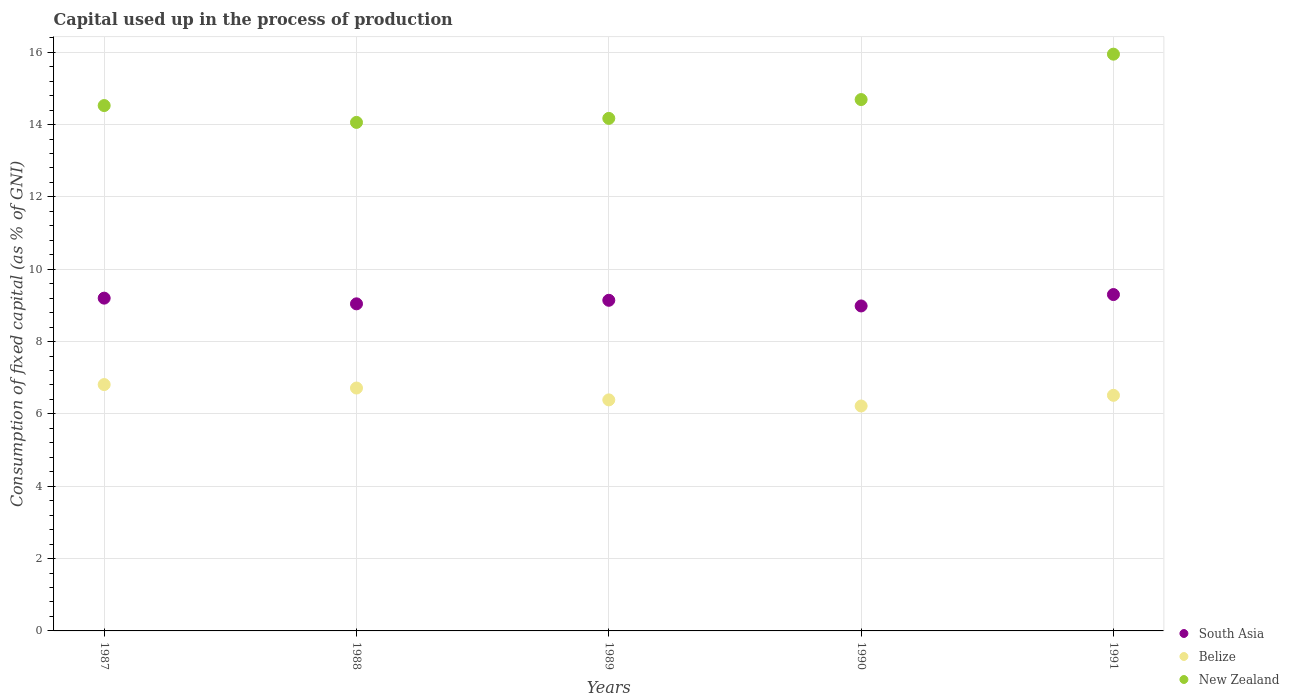What is the capital used up in the process of production in New Zealand in 1987?
Provide a succinct answer. 14.53. Across all years, what is the maximum capital used up in the process of production in South Asia?
Keep it short and to the point. 9.3. Across all years, what is the minimum capital used up in the process of production in Belize?
Provide a succinct answer. 6.22. What is the total capital used up in the process of production in South Asia in the graph?
Give a very brief answer. 45.67. What is the difference between the capital used up in the process of production in South Asia in 1989 and that in 1991?
Give a very brief answer. -0.16. What is the difference between the capital used up in the process of production in New Zealand in 1991 and the capital used up in the process of production in Belize in 1990?
Give a very brief answer. 9.73. What is the average capital used up in the process of production in New Zealand per year?
Make the answer very short. 14.68. In the year 1990, what is the difference between the capital used up in the process of production in New Zealand and capital used up in the process of production in Belize?
Provide a short and direct response. 8.47. What is the ratio of the capital used up in the process of production in South Asia in 1990 to that in 1991?
Your response must be concise. 0.97. Is the capital used up in the process of production in Belize in 1987 less than that in 1990?
Provide a short and direct response. No. Is the difference between the capital used up in the process of production in New Zealand in 1990 and 1991 greater than the difference between the capital used up in the process of production in Belize in 1990 and 1991?
Provide a succinct answer. No. What is the difference between the highest and the second highest capital used up in the process of production in South Asia?
Offer a terse response. 0.1. What is the difference between the highest and the lowest capital used up in the process of production in New Zealand?
Make the answer very short. 1.89. In how many years, is the capital used up in the process of production in South Asia greater than the average capital used up in the process of production in South Asia taken over all years?
Make the answer very short. 3. Is it the case that in every year, the sum of the capital used up in the process of production in Belize and capital used up in the process of production in South Asia  is greater than the capital used up in the process of production in New Zealand?
Give a very brief answer. No. Does the capital used up in the process of production in South Asia monotonically increase over the years?
Keep it short and to the point. No. Is the capital used up in the process of production in Belize strictly greater than the capital used up in the process of production in South Asia over the years?
Your answer should be very brief. No. Is the capital used up in the process of production in South Asia strictly less than the capital used up in the process of production in Belize over the years?
Make the answer very short. No. How many years are there in the graph?
Your answer should be very brief. 5. What is the difference between two consecutive major ticks on the Y-axis?
Offer a very short reply. 2. Does the graph contain any zero values?
Make the answer very short. No. Does the graph contain grids?
Provide a succinct answer. Yes. Where does the legend appear in the graph?
Offer a very short reply. Bottom right. How are the legend labels stacked?
Make the answer very short. Vertical. What is the title of the graph?
Ensure brevity in your answer.  Capital used up in the process of production. What is the label or title of the Y-axis?
Offer a terse response. Consumption of fixed capital (as % of GNI). What is the Consumption of fixed capital (as % of GNI) in South Asia in 1987?
Provide a succinct answer. 9.2. What is the Consumption of fixed capital (as % of GNI) of Belize in 1987?
Offer a very short reply. 6.81. What is the Consumption of fixed capital (as % of GNI) of New Zealand in 1987?
Provide a succinct answer. 14.53. What is the Consumption of fixed capital (as % of GNI) in South Asia in 1988?
Your answer should be compact. 9.04. What is the Consumption of fixed capital (as % of GNI) of Belize in 1988?
Your answer should be very brief. 6.72. What is the Consumption of fixed capital (as % of GNI) of New Zealand in 1988?
Provide a succinct answer. 14.06. What is the Consumption of fixed capital (as % of GNI) in South Asia in 1989?
Your answer should be compact. 9.14. What is the Consumption of fixed capital (as % of GNI) in Belize in 1989?
Make the answer very short. 6.39. What is the Consumption of fixed capital (as % of GNI) of New Zealand in 1989?
Provide a succinct answer. 14.17. What is the Consumption of fixed capital (as % of GNI) of South Asia in 1990?
Make the answer very short. 8.99. What is the Consumption of fixed capital (as % of GNI) in Belize in 1990?
Make the answer very short. 6.22. What is the Consumption of fixed capital (as % of GNI) of New Zealand in 1990?
Provide a succinct answer. 14.69. What is the Consumption of fixed capital (as % of GNI) of South Asia in 1991?
Keep it short and to the point. 9.3. What is the Consumption of fixed capital (as % of GNI) of Belize in 1991?
Offer a very short reply. 6.51. What is the Consumption of fixed capital (as % of GNI) in New Zealand in 1991?
Keep it short and to the point. 15.95. Across all years, what is the maximum Consumption of fixed capital (as % of GNI) of South Asia?
Keep it short and to the point. 9.3. Across all years, what is the maximum Consumption of fixed capital (as % of GNI) of Belize?
Ensure brevity in your answer.  6.81. Across all years, what is the maximum Consumption of fixed capital (as % of GNI) of New Zealand?
Your answer should be compact. 15.95. Across all years, what is the minimum Consumption of fixed capital (as % of GNI) in South Asia?
Offer a very short reply. 8.99. Across all years, what is the minimum Consumption of fixed capital (as % of GNI) in Belize?
Make the answer very short. 6.22. Across all years, what is the minimum Consumption of fixed capital (as % of GNI) in New Zealand?
Your answer should be very brief. 14.06. What is the total Consumption of fixed capital (as % of GNI) of South Asia in the graph?
Keep it short and to the point. 45.67. What is the total Consumption of fixed capital (as % of GNI) of Belize in the graph?
Ensure brevity in your answer.  32.65. What is the total Consumption of fixed capital (as % of GNI) in New Zealand in the graph?
Your answer should be compact. 73.4. What is the difference between the Consumption of fixed capital (as % of GNI) in South Asia in 1987 and that in 1988?
Provide a short and direct response. 0.16. What is the difference between the Consumption of fixed capital (as % of GNI) of Belize in 1987 and that in 1988?
Ensure brevity in your answer.  0.1. What is the difference between the Consumption of fixed capital (as % of GNI) of New Zealand in 1987 and that in 1988?
Your answer should be compact. 0.47. What is the difference between the Consumption of fixed capital (as % of GNI) of South Asia in 1987 and that in 1989?
Make the answer very short. 0.06. What is the difference between the Consumption of fixed capital (as % of GNI) of Belize in 1987 and that in 1989?
Keep it short and to the point. 0.42. What is the difference between the Consumption of fixed capital (as % of GNI) of New Zealand in 1987 and that in 1989?
Give a very brief answer. 0.35. What is the difference between the Consumption of fixed capital (as % of GNI) in South Asia in 1987 and that in 1990?
Your answer should be compact. 0.22. What is the difference between the Consumption of fixed capital (as % of GNI) of Belize in 1987 and that in 1990?
Make the answer very short. 0.59. What is the difference between the Consumption of fixed capital (as % of GNI) of New Zealand in 1987 and that in 1990?
Provide a succinct answer. -0.17. What is the difference between the Consumption of fixed capital (as % of GNI) in South Asia in 1987 and that in 1991?
Keep it short and to the point. -0.1. What is the difference between the Consumption of fixed capital (as % of GNI) of Belize in 1987 and that in 1991?
Your answer should be very brief. 0.3. What is the difference between the Consumption of fixed capital (as % of GNI) of New Zealand in 1987 and that in 1991?
Offer a terse response. -1.42. What is the difference between the Consumption of fixed capital (as % of GNI) in South Asia in 1988 and that in 1989?
Your answer should be compact. -0.1. What is the difference between the Consumption of fixed capital (as % of GNI) in Belize in 1988 and that in 1989?
Keep it short and to the point. 0.33. What is the difference between the Consumption of fixed capital (as % of GNI) of New Zealand in 1988 and that in 1989?
Ensure brevity in your answer.  -0.11. What is the difference between the Consumption of fixed capital (as % of GNI) of South Asia in 1988 and that in 1990?
Offer a terse response. 0.06. What is the difference between the Consumption of fixed capital (as % of GNI) in Belize in 1988 and that in 1990?
Provide a short and direct response. 0.5. What is the difference between the Consumption of fixed capital (as % of GNI) of New Zealand in 1988 and that in 1990?
Your response must be concise. -0.63. What is the difference between the Consumption of fixed capital (as % of GNI) of South Asia in 1988 and that in 1991?
Keep it short and to the point. -0.26. What is the difference between the Consumption of fixed capital (as % of GNI) in Belize in 1988 and that in 1991?
Ensure brevity in your answer.  0.2. What is the difference between the Consumption of fixed capital (as % of GNI) of New Zealand in 1988 and that in 1991?
Make the answer very short. -1.89. What is the difference between the Consumption of fixed capital (as % of GNI) of South Asia in 1989 and that in 1990?
Your answer should be very brief. 0.16. What is the difference between the Consumption of fixed capital (as % of GNI) of Belize in 1989 and that in 1990?
Provide a short and direct response. 0.17. What is the difference between the Consumption of fixed capital (as % of GNI) in New Zealand in 1989 and that in 1990?
Make the answer very short. -0.52. What is the difference between the Consumption of fixed capital (as % of GNI) of South Asia in 1989 and that in 1991?
Ensure brevity in your answer.  -0.16. What is the difference between the Consumption of fixed capital (as % of GNI) of Belize in 1989 and that in 1991?
Give a very brief answer. -0.13. What is the difference between the Consumption of fixed capital (as % of GNI) in New Zealand in 1989 and that in 1991?
Offer a terse response. -1.78. What is the difference between the Consumption of fixed capital (as % of GNI) in South Asia in 1990 and that in 1991?
Provide a succinct answer. -0.32. What is the difference between the Consumption of fixed capital (as % of GNI) in Belize in 1990 and that in 1991?
Offer a very short reply. -0.3. What is the difference between the Consumption of fixed capital (as % of GNI) in New Zealand in 1990 and that in 1991?
Your answer should be very brief. -1.26. What is the difference between the Consumption of fixed capital (as % of GNI) in South Asia in 1987 and the Consumption of fixed capital (as % of GNI) in Belize in 1988?
Provide a succinct answer. 2.49. What is the difference between the Consumption of fixed capital (as % of GNI) in South Asia in 1987 and the Consumption of fixed capital (as % of GNI) in New Zealand in 1988?
Offer a terse response. -4.86. What is the difference between the Consumption of fixed capital (as % of GNI) of Belize in 1987 and the Consumption of fixed capital (as % of GNI) of New Zealand in 1988?
Give a very brief answer. -7.25. What is the difference between the Consumption of fixed capital (as % of GNI) in South Asia in 1987 and the Consumption of fixed capital (as % of GNI) in Belize in 1989?
Give a very brief answer. 2.81. What is the difference between the Consumption of fixed capital (as % of GNI) in South Asia in 1987 and the Consumption of fixed capital (as % of GNI) in New Zealand in 1989?
Ensure brevity in your answer.  -4.97. What is the difference between the Consumption of fixed capital (as % of GNI) in Belize in 1987 and the Consumption of fixed capital (as % of GNI) in New Zealand in 1989?
Your answer should be very brief. -7.36. What is the difference between the Consumption of fixed capital (as % of GNI) of South Asia in 1987 and the Consumption of fixed capital (as % of GNI) of Belize in 1990?
Ensure brevity in your answer.  2.98. What is the difference between the Consumption of fixed capital (as % of GNI) in South Asia in 1987 and the Consumption of fixed capital (as % of GNI) in New Zealand in 1990?
Provide a succinct answer. -5.49. What is the difference between the Consumption of fixed capital (as % of GNI) of Belize in 1987 and the Consumption of fixed capital (as % of GNI) of New Zealand in 1990?
Make the answer very short. -7.88. What is the difference between the Consumption of fixed capital (as % of GNI) of South Asia in 1987 and the Consumption of fixed capital (as % of GNI) of Belize in 1991?
Offer a very short reply. 2.69. What is the difference between the Consumption of fixed capital (as % of GNI) of South Asia in 1987 and the Consumption of fixed capital (as % of GNI) of New Zealand in 1991?
Make the answer very short. -6.75. What is the difference between the Consumption of fixed capital (as % of GNI) in Belize in 1987 and the Consumption of fixed capital (as % of GNI) in New Zealand in 1991?
Offer a very short reply. -9.14. What is the difference between the Consumption of fixed capital (as % of GNI) of South Asia in 1988 and the Consumption of fixed capital (as % of GNI) of Belize in 1989?
Provide a short and direct response. 2.66. What is the difference between the Consumption of fixed capital (as % of GNI) of South Asia in 1988 and the Consumption of fixed capital (as % of GNI) of New Zealand in 1989?
Make the answer very short. -5.13. What is the difference between the Consumption of fixed capital (as % of GNI) in Belize in 1988 and the Consumption of fixed capital (as % of GNI) in New Zealand in 1989?
Your answer should be compact. -7.46. What is the difference between the Consumption of fixed capital (as % of GNI) in South Asia in 1988 and the Consumption of fixed capital (as % of GNI) in Belize in 1990?
Provide a succinct answer. 2.82. What is the difference between the Consumption of fixed capital (as % of GNI) of South Asia in 1988 and the Consumption of fixed capital (as % of GNI) of New Zealand in 1990?
Give a very brief answer. -5.65. What is the difference between the Consumption of fixed capital (as % of GNI) of Belize in 1988 and the Consumption of fixed capital (as % of GNI) of New Zealand in 1990?
Provide a short and direct response. -7.98. What is the difference between the Consumption of fixed capital (as % of GNI) in South Asia in 1988 and the Consumption of fixed capital (as % of GNI) in Belize in 1991?
Provide a succinct answer. 2.53. What is the difference between the Consumption of fixed capital (as % of GNI) in South Asia in 1988 and the Consumption of fixed capital (as % of GNI) in New Zealand in 1991?
Offer a terse response. -6.9. What is the difference between the Consumption of fixed capital (as % of GNI) of Belize in 1988 and the Consumption of fixed capital (as % of GNI) of New Zealand in 1991?
Your response must be concise. -9.23. What is the difference between the Consumption of fixed capital (as % of GNI) of South Asia in 1989 and the Consumption of fixed capital (as % of GNI) of Belize in 1990?
Give a very brief answer. 2.92. What is the difference between the Consumption of fixed capital (as % of GNI) in South Asia in 1989 and the Consumption of fixed capital (as % of GNI) in New Zealand in 1990?
Provide a succinct answer. -5.55. What is the difference between the Consumption of fixed capital (as % of GNI) of Belize in 1989 and the Consumption of fixed capital (as % of GNI) of New Zealand in 1990?
Make the answer very short. -8.3. What is the difference between the Consumption of fixed capital (as % of GNI) in South Asia in 1989 and the Consumption of fixed capital (as % of GNI) in Belize in 1991?
Give a very brief answer. 2.63. What is the difference between the Consumption of fixed capital (as % of GNI) of South Asia in 1989 and the Consumption of fixed capital (as % of GNI) of New Zealand in 1991?
Offer a terse response. -6.81. What is the difference between the Consumption of fixed capital (as % of GNI) in Belize in 1989 and the Consumption of fixed capital (as % of GNI) in New Zealand in 1991?
Offer a very short reply. -9.56. What is the difference between the Consumption of fixed capital (as % of GNI) in South Asia in 1990 and the Consumption of fixed capital (as % of GNI) in Belize in 1991?
Provide a succinct answer. 2.47. What is the difference between the Consumption of fixed capital (as % of GNI) in South Asia in 1990 and the Consumption of fixed capital (as % of GNI) in New Zealand in 1991?
Provide a short and direct response. -6.96. What is the difference between the Consumption of fixed capital (as % of GNI) in Belize in 1990 and the Consumption of fixed capital (as % of GNI) in New Zealand in 1991?
Provide a short and direct response. -9.73. What is the average Consumption of fixed capital (as % of GNI) of South Asia per year?
Your answer should be compact. 9.13. What is the average Consumption of fixed capital (as % of GNI) in Belize per year?
Provide a succinct answer. 6.53. What is the average Consumption of fixed capital (as % of GNI) in New Zealand per year?
Make the answer very short. 14.68. In the year 1987, what is the difference between the Consumption of fixed capital (as % of GNI) in South Asia and Consumption of fixed capital (as % of GNI) in Belize?
Your response must be concise. 2.39. In the year 1987, what is the difference between the Consumption of fixed capital (as % of GNI) of South Asia and Consumption of fixed capital (as % of GNI) of New Zealand?
Your answer should be very brief. -5.32. In the year 1987, what is the difference between the Consumption of fixed capital (as % of GNI) of Belize and Consumption of fixed capital (as % of GNI) of New Zealand?
Your answer should be very brief. -7.71. In the year 1988, what is the difference between the Consumption of fixed capital (as % of GNI) of South Asia and Consumption of fixed capital (as % of GNI) of Belize?
Provide a short and direct response. 2.33. In the year 1988, what is the difference between the Consumption of fixed capital (as % of GNI) of South Asia and Consumption of fixed capital (as % of GNI) of New Zealand?
Provide a succinct answer. -5.02. In the year 1988, what is the difference between the Consumption of fixed capital (as % of GNI) of Belize and Consumption of fixed capital (as % of GNI) of New Zealand?
Keep it short and to the point. -7.34. In the year 1989, what is the difference between the Consumption of fixed capital (as % of GNI) in South Asia and Consumption of fixed capital (as % of GNI) in Belize?
Ensure brevity in your answer.  2.75. In the year 1989, what is the difference between the Consumption of fixed capital (as % of GNI) in South Asia and Consumption of fixed capital (as % of GNI) in New Zealand?
Give a very brief answer. -5.03. In the year 1989, what is the difference between the Consumption of fixed capital (as % of GNI) of Belize and Consumption of fixed capital (as % of GNI) of New Zealand?
Ensure brevity in your answer.  -7.78. In the year 1990, what is the difference between the Consumption of fixed capital (as % of GNI) in South Asia and Consumption of fixed capital (as % of GNI) in Belize?
Your answer should be very brief. 2.77. In the year 1990, what is the difference between the Consumption of fixed capital (as % of GNI) in South Asia and Consumption of fixed capital (as % of GNI) in New Zealand?
Provide a short and direct response. -5.71. In the year 1990, what is the difference between the Consumption of fixed capital (as % of GNI) of Belize and Consumption of fixed capital (as % of GNI) of New Zealand?
Keep it short and to the point. -8.47. In the year 1991, what is the difference between the Consumption of fixed capital (as % of GNI) of South Asia and Consumption of fixed capital (as % of GNI) of Belize?
Give a very brief answer. 2.79. In the year 1991, what is the difference between the Consumption of fixed capital (as % of GNI) in South Asia and Consumption of fixed capital (as % of GNI) in New Zealand?
Provide a short and direct response. -6.65. In the year 1991, what is the difference between the Consumption of fixed capital (as % of GNI) in Belize and Consumption of fixed capital (as % of GNI) in New Zealand?
Offer a very short reply. -9.43. What is the ratio of the Consumption of fixed capital (as % of GNI) of South Asia in 1987 to that in 1988?
Ensure brevity in your answer.  1.02. What is the ratio of the Consumption of fixed capital (as % of GNI) in Belize in 1987 to that in 1988?
Your answer should be very brief. 1.01. What is the ratio of the Consumption of fixed capital (as % of GNI) in New Zealand in 1987 to that in 1988?
Provide a succinct answer. 1.03. What is the ratio of the Consumption of fixed capital (as % of GNI) of Belize in 1987 to that in 1989?
Offer a very short reply. 1.07. What is the ratio of the Consumption of fixed capital (as % of GNI) in New Zealand in 1987 to that in 1989?
Your response must be concise. 1.02. What is the ratio of the Consumption of fixed capital (as % of GNI) of South Asia in 1987 to that in 1990?
Offer a terse response. 1.02. What is the ratio of the Consumption of fixed capital (as % of GNI) in Belize in 1987 to that in 1990?
Keep it short and to the point. 1.1. What is the ratio of the Consumption of fixed capital (as % of GNI) in New Zealand in 1987 to that in 1990?
Make the answer very short. 0.99. What is the ratio of the Consumption of fixed capital (as % of GNI) in South Asia in 1987 to that in 1991?
Your response must be concise. 0.99. What is the ratio of the Consumption of fixed capital (as % of GNI) in Belize in 1987 to that in 1991?
Make the answer very short. 1.05. What is the ratio of the Consumption of fixed capital (as % of GNI) in New Zealand in 1987 to that in 1991?
Your response must be concise. 0.91. What is the ratio of the Consumption of fixed capital (as % of GNI) of South Asia in 1988 to that in 1989?
Offer a terse response. 0.99. What is the ratio of the Consumption of fixed capital (as % of GNI) of Belize in 1988 to that in 1989?
Ensure brevity in your answer.  1.05. What is the ratio of the Consumption of fixed capital (as % of GNI) in South Asia in 1988 to that in 1990?
Your answer should be very brief. 1.01. What is the ratio of the Consumption of fixed capital (as % of GNI) of Belize in 1988 to that in 1990?
Offer a very short reply. 1.08. What is the ratio of the Consumption of fixed capital (as % of GNI) in South Asia in 1988 to that in 1991?
Your response must be concise. 0.97. What is the ratio of the Consumption of fixed capital (as % of GNI) of Belize in 1988 to that in 1991?
Provide a succinct answer. 1.03. What is the ratio of the Consumption of fixed capital (as % of GNI) in New Zealand in 1988 to that in 1991?
Make the answer very short. 0.88. What is the ratio of the Consumption of fixed capital (as % of GNI) in South Asia in 1989 to that in 1990?
Offer a terse response. 1.02. What is the ratio of the Consumption of fixed capital (as % of GNI) in Belize in 1989 to that in 1990?
Your answer should be compact. 1.03. What is the ratio of the Consumption of fixed capital (as % of GNI) in New Zealand in 1989 to that in 1990?
Your response must be concise. 0.96. What is the ratio of the Consumption of fixed capital (as % of GNI) in South Asia in 1989 to that in 1991?
Your response must be concise. 0.98. What is the ratio of the Consumption of fixed capital (as % of GNI) in Belize in 1989 to that in 1991?
Your response must be concise. 0.98. What is the ratio of the Consumption of fixed capital (as % of GNI) of New Zealand in 1989 to that in 1991?
Keep it short and to the point. 0.89. What is the ratio of the Consumption of fixed capital (as % of GNI) of South Asia in 1990 to that in 1991?
Offer a terse response. 0.97. What is the ratio of the Consumption of fixed capital (as % of GNI) of Belize in 1990 to that in 1991?
Ensure brevity in your answer.  0.95. What is the ratio of the Consumption of fixed capital (as % of GNI) in New Zealand in 1990 to that in 1991?
Ensure brevity in your answer.  0.92. What is the difference between the highest and the second highest Consumption of fixed capital (as % of GNI) of South Asia?
Provide a succinct answer. 0.1. What is the difference between the highest and the second highest Consumption of fixed capital (as % of GNI) of Belize?
Your response must be concise. 0.1. What is the difference between the highest and the second highest Consumption of fixed capital (as % of GNI) in New Zealand?
Keep it short and to the point. 1.26. What is the difference between the highest and the lowest Consumption of fixed capital (as % of GNI) of South Asia?
Ensure brevity in your answer.  0.32. What is the difference between the highest and the lowest Consumption of fixed capital (as % of GNI) of Belize?
Your response must be concise. 0.59. What is the difference between the highest and the lowest Consumption of fixed capital (as % of GNI) of New Zealand?
Offer a terse response. 1.89. 